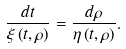<formula> <loc_0><loc_0><loc_500><loc_500>\frac { d t } { \xi \left ( t , \rho \right ) } = \frac { d \rho } { \eta \left ( t , \rho \right ) } .</formula> 